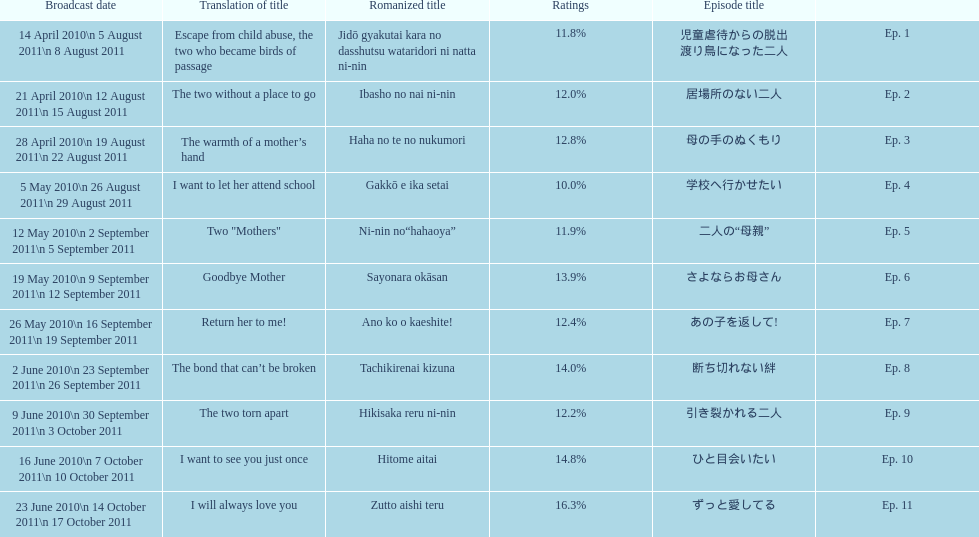How many episodes were broadcast in april 2010 in japan? 3. 